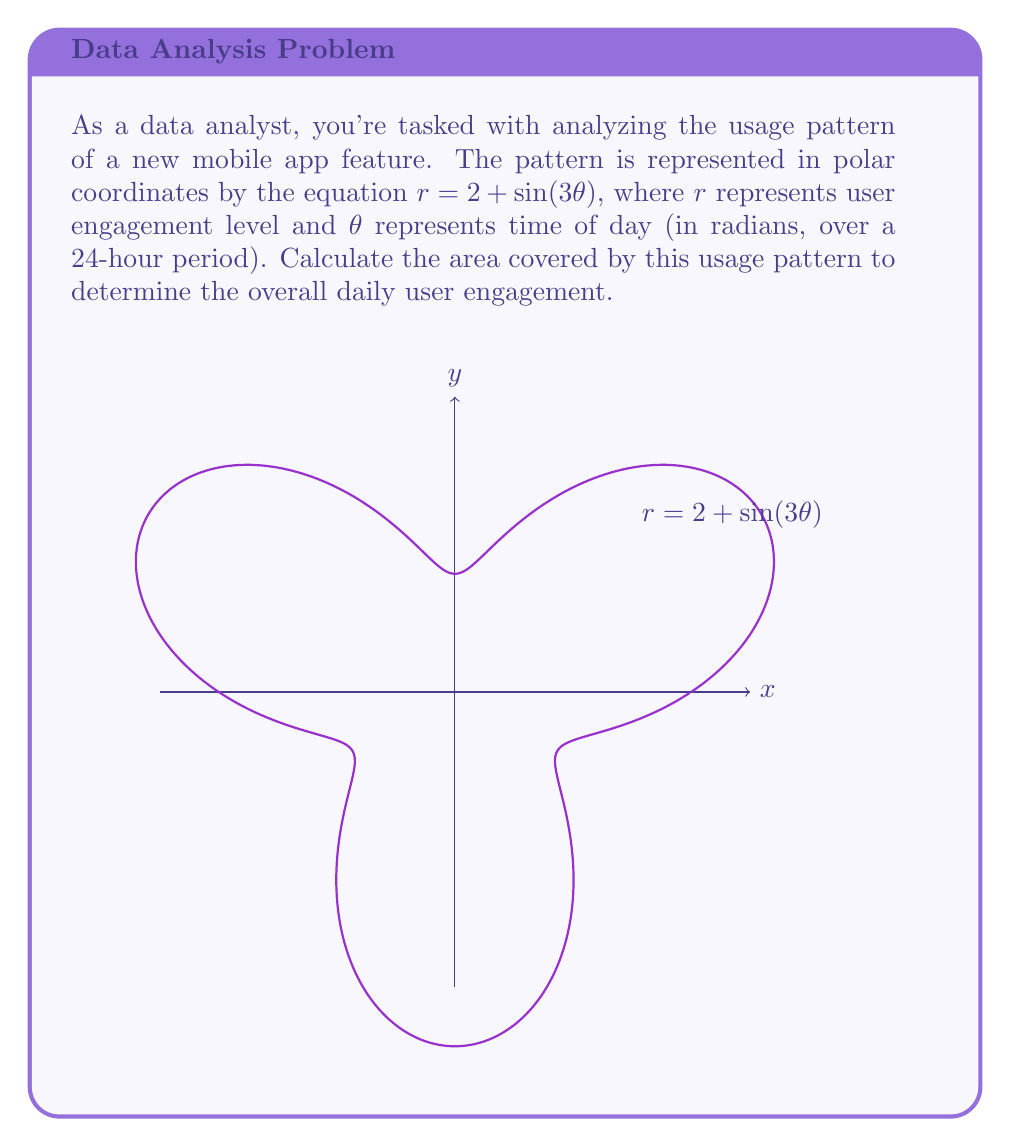What is the answer to this math problem? To calculate the area enclosed by a polar curve, we use the formula:

$$ A = \frac{1}{2} \int_0^{2\pi} r^2(\theta) d\theta $$

For our curve $r = 2 + \sin(3\theta)$, we need to:

1) Square $r$:
   $r^2 = (2 + \sin(3\theta))^2 = 4 + 4\sin(3\theta) + \sin^2(3\theta)$

2) Integrate from 0 to $2\pi$:
   $$ A = \frac{1}{2} \int_0^{2\pi} (4 + 4\sin(3\theta) + \sin^2(3\theta)) d\theta $$

3) Integrate each term:
   - $\int_0^{2\pi} 4 d\theta = 4\theta \big|_0^{2\pi} = 8\pi$
   - $\int_0^{2\pi} 4\sin(3\theta) d\theta = -\frac{4}{3}\cos(3\theta) \big|_0^{2\pi} = 0$
   - $\int_0^{2\pi} \sin^2(3\theta) d\theta = \int_0^{2\pi} \frac{1-\cos(6\theta)}{2} d\theta = \frac{\theta}{2} - \frac{\sin(6\theta)}{12} \big|_0^{2\pi} = \pi$

4) Sum the results:
   $$ A = \frac{1}{2} (8\pi + 0 + \pi) = \frac{9\pi}{2} $$

Thus, the area covered by the usage pattern is $\frac{9\pi}{2}$ square units.
Answer: $\frac{9\pi}{2}$ square units 